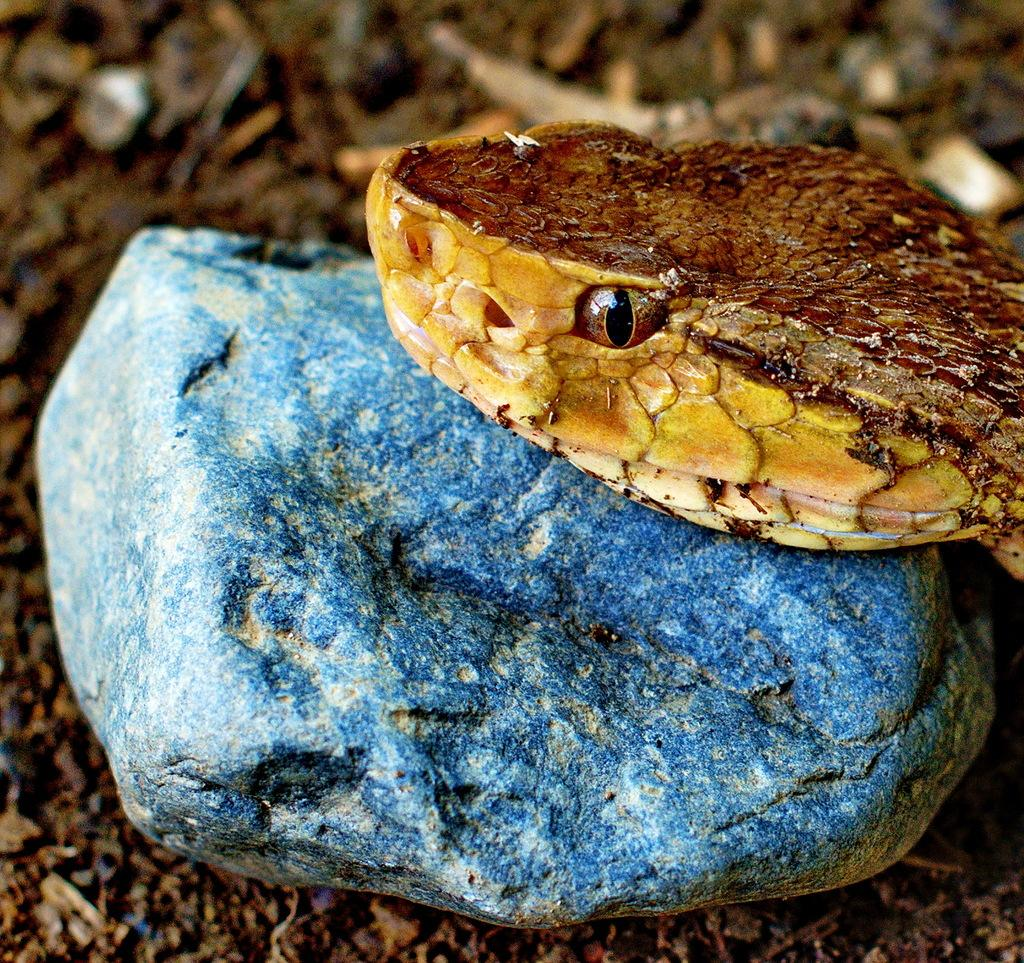What is the main subject of the image? The main subject of the image is a snake head. Where is the snake head located? The snake head is on a rock. What is the rock situated on? The rock is on the land. What arithmetic problem is the snake head solving in the image? There is no arithmetic problem present in the image. What type of teeth can be seen on the snake head in the image? The image does not show the snake head's teeth, so it cannot be determined from the image. What type of bun is visible on the snake head in the image? There is no bun present on the snake head in the image. 